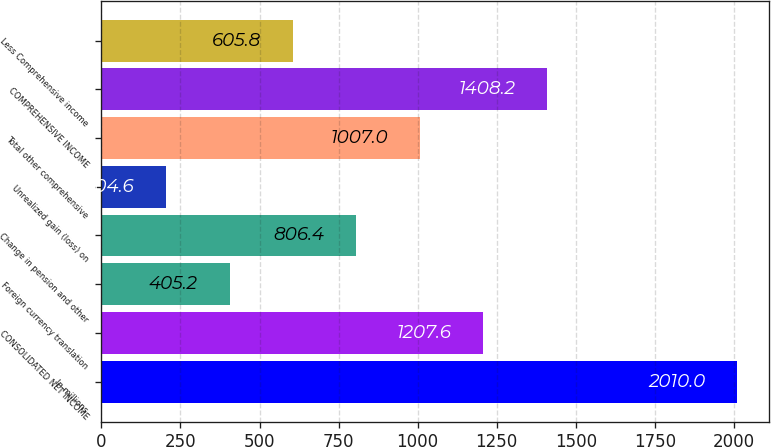<chart> <loc_0><loc_0><loc_500><loc_500><bar_chart><fcel>In millions<fcel>CONSOLIDATED NET INCOME<fcel>Foreign currency translation<fcel>Change in pension and other<fcel>Unrealized gain (loss) on<fcel>Total other comprehensive<fcel>COMPREHENSIVE INCOME<fcel>Less Comprehensive income<nl><fcel>2010<fcel>1207.6<fcel>405.2<fcel>806.4<fcel>204.6<fcel>1007<fcel>1408.2<fcel>605.8<nl></chart> 